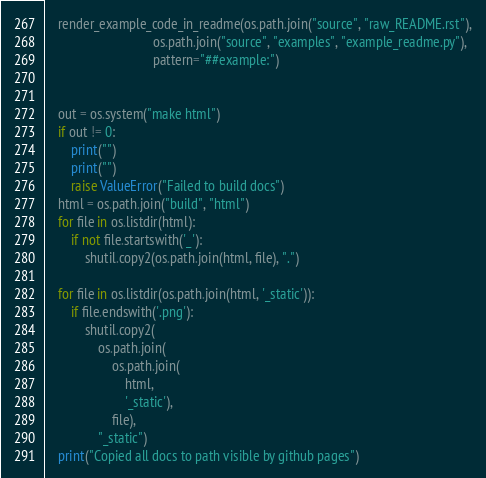<code> <loc_0><loc_0><loc_500><loc_500><_Python_>
    render_example_code_in_readme(os.path.join("source", "raw_README.rst"),
                                os.path.join("source", "examples", "example_readme.py"),
                                pattern="##example:")


    out = os.system("make html")
    if out != 0:
        print("")
        print("")
        raise ValueError("Failed to build docs")
    html = os.path.join("build", "html")
    for file in os.listdir(html):
        if not file.startswith('_'):
            shutil.copy2(os.path.join(html, file), ".")

    for file in os.listdir(os.path.join(html, '_static')):
        if file.endswith('.png'):
            shutil.copy2(
                os.path.join(
                    os.path.join(
                        html,
                        '_static'),
                    file),
                "_static")
    print("Copied all docs to path visible by github pages")
</code> 